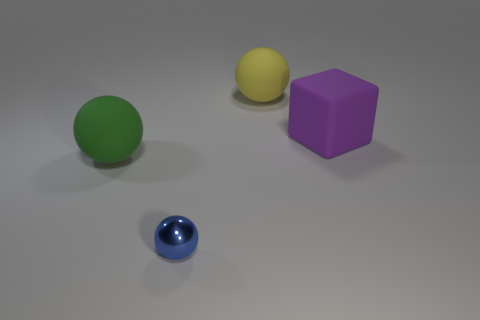What size is the green object?
Provide a short and direct response. Large. There is a object that is in front of the green matte sphere; what size is it?
Provide a short and direct response. Small. What is the shape of the thing that is in front of the large purple rubber thing and behind the small blue thing?
Your response must be concise. Sphere. What number of other objects are the same shape as the green rubber object?
Ensure brevity in your answer.  2. There is a rubber block that is the same size as the green matte object; what color is it?
Keep it short and to the point. Purple. What number of objects are either rubber things or large green rubber cubes?
Keep it short and to the point. 3. Are there any objects in front of the large purple rubber block?
Ensure brevity in your answer.  Yes. Are there any green spheres that have the same material as the big yellow thing?
Your response must be concise. Yes. How many balls are green things or big yellow matte things?
Keep it short and to the point. 2. Is the number of large matte objects left of the big yellow object greater than the number of metallic things right of the purple matte object?
Ensure brevity in your answer.  Yes. 